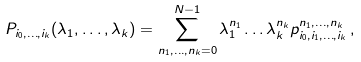<formula> <loc_0><loc_0><loc_500><loc_500>P _ { i _ { 0 } , \dots , i _ { k } } ( \lambda _ { 1 } , \dots , \lambda _ { k } ) = \sum _ { n _ { 1 } , \dots , n _ { k } = 0 } ^ { N - 1 } \lambda _ { 1 } ^ { n _ { 1 } } \dots \lambda _ { k } ^ { n _ { k } } p ^ { n _ { 1 } , \dots , n _ { k } } _ { i _ { 0 } , i _ { 1 } , \dots , i _ { k } } \, ,</formula> 